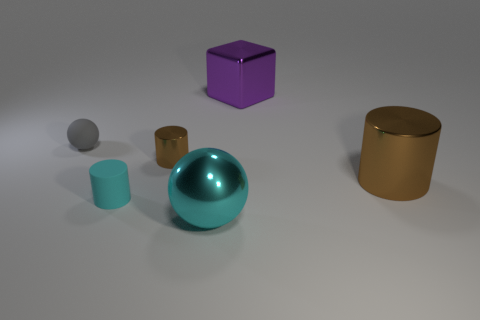The tiny rubber thing that is to the right of the small matte thing that is behind the small brown shiny thing is what shape?
Offer a terse response. Cylinder. There is a tiny thing in front of the big brown thing; how many tiny cylinders are behind it?
Your answer should be compact. 1. What material is the large object that is both behind the cyan rubber cylinder and in front of the purple block?
Make the answer very short. Metal. What shape is the shiny thing that is the same size as the cyan matte thing?
Offer a very short reply. Cylinder. The large object that is in front of the shiny cylinder that is in front of the tiny object right of the tiny rubber cylinder is what color?
Your response must be concise. Cyan. How many objects are either matte things in front of the big brown metallic cylinder or tiny rubber spheres?
Your answer should be compact. 2. What material is the brown cylinder that is the same size as the cyan ball?
Give a very brief answer. Metal. There is a sphere in front of the brown cylinder on the left side of the brown cylinder to the right of the purple cube; what is its material?
Ensure brevity in your answer.  Metal. The rubber sphere is what color?
Offer a terse response. Gray. How many small things are gray objects or brown cylinders?
Provide a succinct answer. 2. 